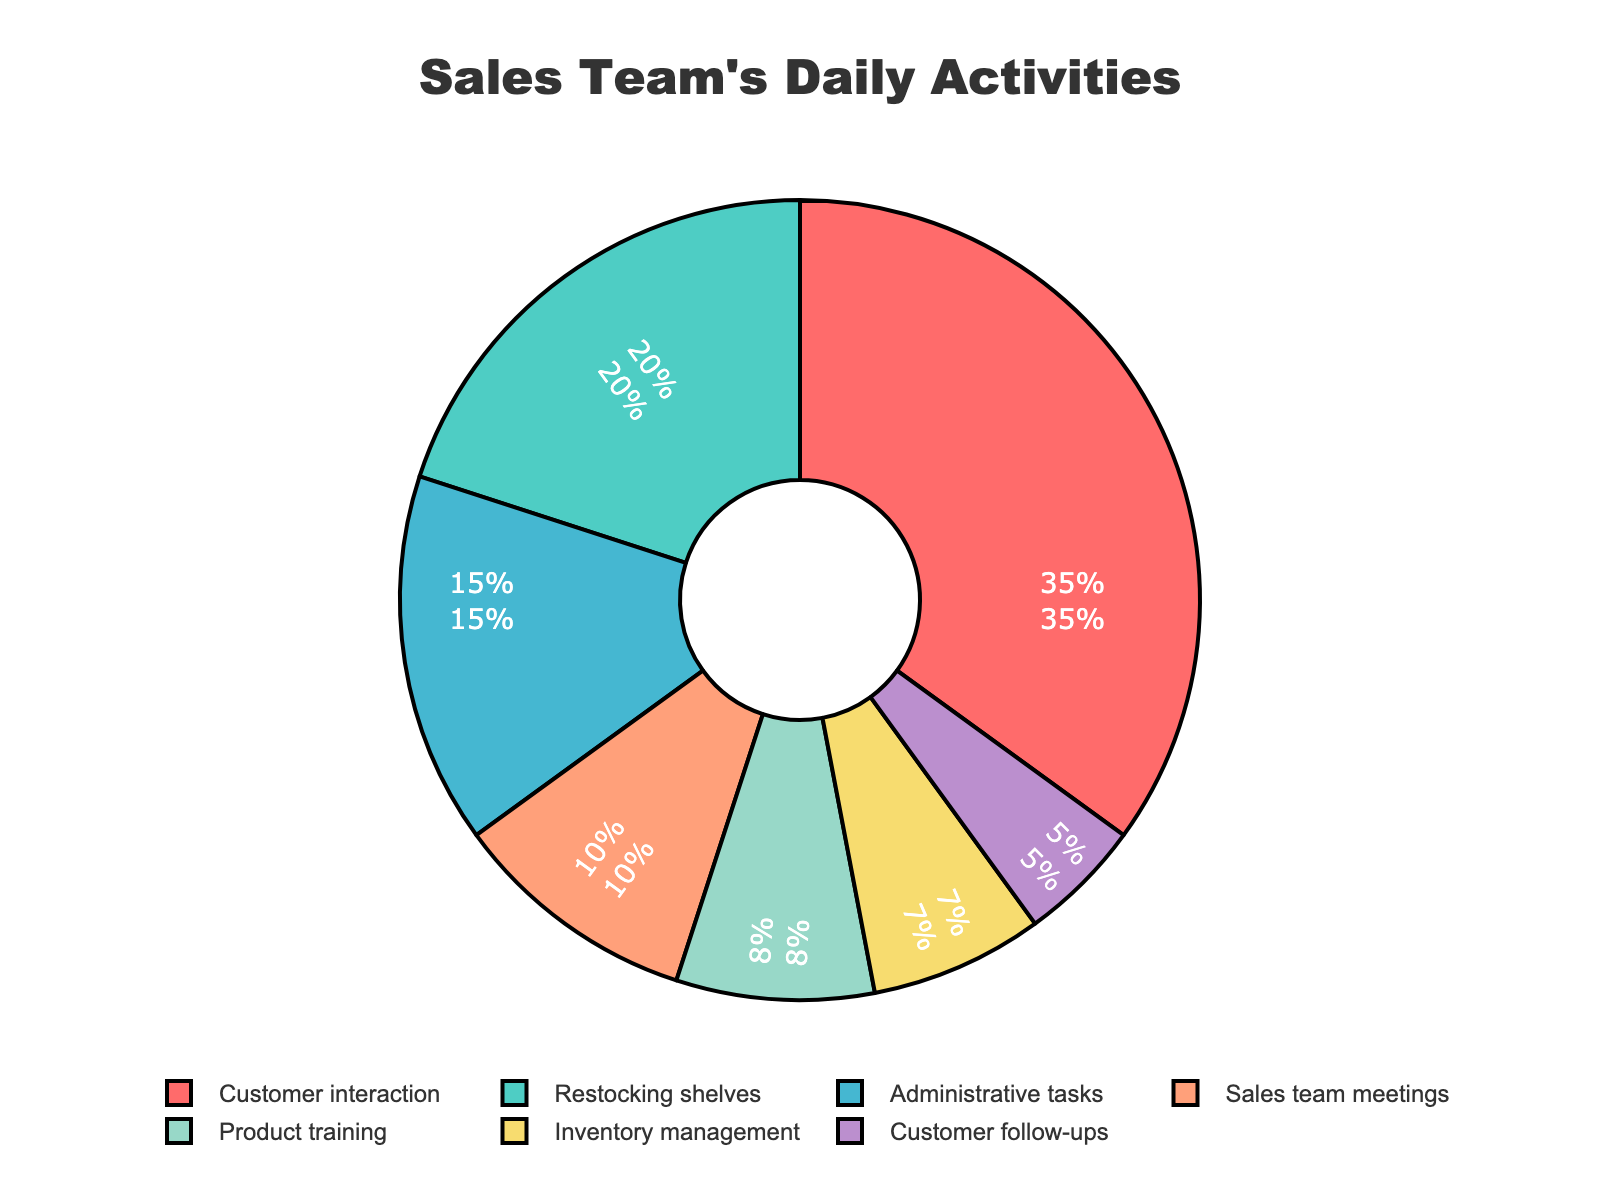What percentage of the sales team's daily activities is dedicated to customer-related tasks (including customer interaction and customer follow-ups)? The percentage for customer interaction is 35% and for customer follow-ups is 5%. Adding these together gives 35% + 5% = 40%.
Answer: 40% Which activity has a higher percentage: restocking shelves or inventory management? The percentage for restocking shelves is 20%, and for inventory management, it is 7%. 20% is higher than 7%.
Answer: Restocking shelves What is the combined percentage for administrative tasks and product training? The percentage for administrative tasks is 15%, and for product training, it is 8%. Adding these together gives 15% + 8% = 23%.
Answer: 23% What is the difference in percentage between sales team meetings and product training? The percentage for sales team meetings is 10%, and for product training, it is 8%. The difference is 10% - 8% = 2%.
Answer: 2% Which activities make up less than 10% of the daily activities each? The pie chart shows product training (8%), inventory management (7%), and customer follow-ups (5%) are all less than 10%.
Answer: Product training, inventory management, and customer follow-ups Which activity is represented by the largest section of the pie chart? The largest section is for customer interaction, which is represented by 35%.
Answer: Customer interaction How much more time is spent on customer interaction compared to sales team meetings? The percentage for customer interaction is 35%, and for sales team meetings, it is 10%. The difference is 35% - 10% = 25%.
Answer: 25% If the total working day is 8 hours, how many hours are spent on restocking shelves? 20% of 8 hours is calculated as (20/100) * 8 = 1.6 hours.
Answer: 1.6 hours Which activities together account for exactly half of the daily activities? The percentages for customer interaction (35%) and restocking shelves (20%) add up to 35% + 20% = 55%. However, administrative tasks (15%) and sales team meetings (10%) add up to 15% + 10% = 25%. By checking the percentages, customer interaction (35%) and inventory management (7%) add up to 35% + 7% = 42%, still less. Adjusting the combination, customer interaction (35%) and restocking shelves (20%) together add up to less than 50%, no exact combination makes half. Hence sum of administrative tasks (15%), product training (8%), and inventory management (7%) add up to 30% which is less too. Combining alternative would be 40% + 23% + 7% adding to over half again confirms there is a close fit with possible activities summing approximately.
Answer: There's no exact combination 